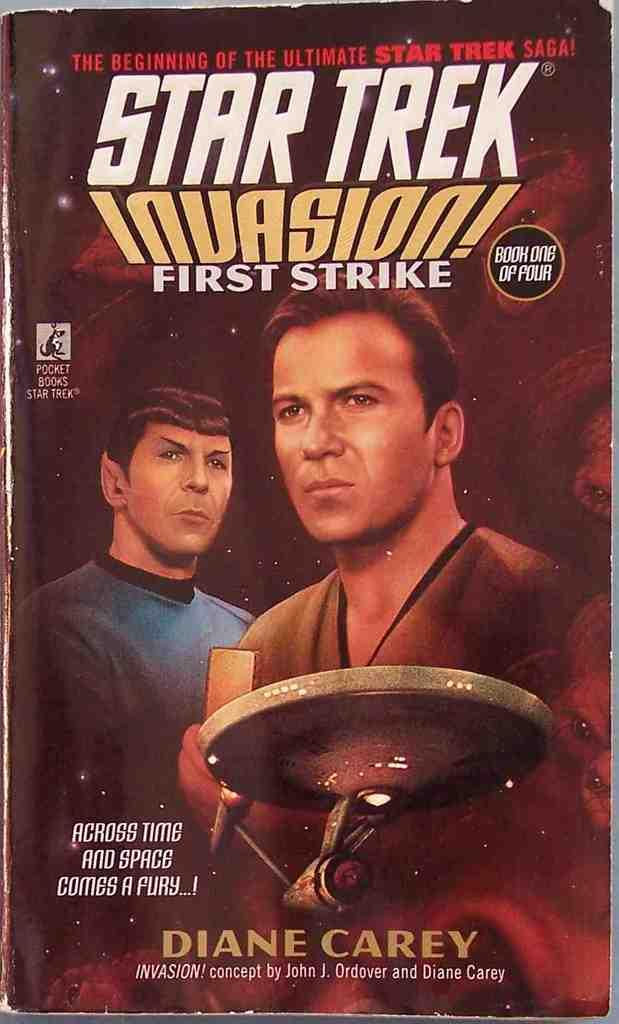<image>
Create a compact narrative representing the image presented. The cover for the book titled star trek invasion by Diane Carey. 